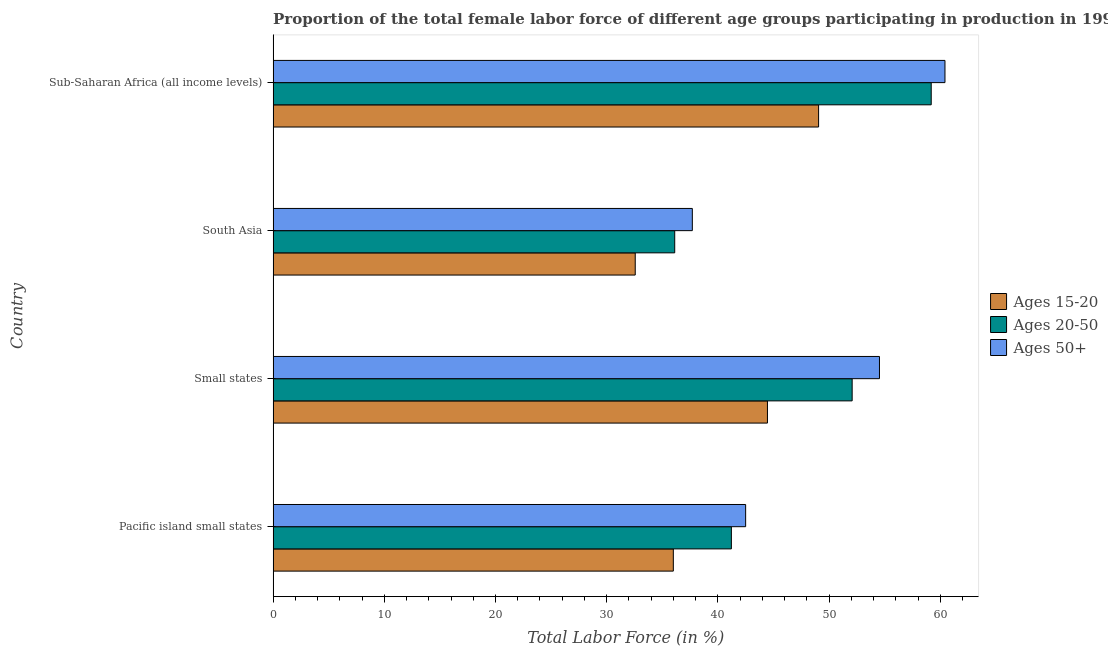How many different coloured bars are there?
Your answer should be very brief. 3. Are the number of bars on each tick of the Y-axis equal?
Keep it short and to the point. Yes. How many bars are there on the 1st tick from the top?
Provide a succinct answer. 3. What is the label of the 4th group of bars from the top?
Your response must be concise. Pacific island small states. In how many cases, is the number of bars for a given country not equal to the number of legend labels?
Your answer should be compact. 0. What is the percentage of female labor force within the age group 15-20 in Pacific island small states?
Provide a short and direct response. 35.99. Across all countries, what is the maximum percentage of female labor force within the age group 15-20?
Your answer should be very brief. 49.06. Across all countries, what is the minimum percentage of female labor force above age 50?
Offer a terse response. 37.7. In which country was the percentage of female labor force within the age group 20-50 maximum?
Offer a very short reply. Sub-Saharan Africa (all income levels). What is the total percentage of female labor force within the age group 20-50 in the graph?
Provide a succinct answer. 188.6. What is the difference between the percentage of female labor force within the age group 20-50 in Small states and that in Sub-Saharan Africa (all income levels)?
Your response must be concise. -7.11. What is the difference between the percentage of female labor force within the age group 20-50 in South Asia and the percentage of female labor force within the age group 15-20 in Small states?
Provide a succinct answer. -8.34. What is the average percentage of female labor force within the age group 15-20 per country?
Keep it short and to the point. 40.52. What is the difference between the percentage of female labor force above age 50 and percentage of female labor force within the age group 15-20 in Small states?
Provide a short and direct response. 10.07. In how many countries, is the percentage of female labor force within the age group 20-50 greater than 44 %?
Keep it short and to the point. 2. What is the ratio of the percentage of female labor force within the age group 20-50 in Small states to that in South Asia?
Your response must be concise. 1.44. What is the difference between the highest and the second highest percentage of female labor force within the age group 20-50?
Offer a very short reply. 7.11. What is the difference between the highest and the lowest percentage of female labor force within the age group 20-50?
Provide a short and direct response. 23.07. Is the sum of the percentage of female labor force above age 50 in Small states and Sub-Saharan Africa (all income levels) greater than the maximum percentage of female labor force within the age group 20-50 across all countries?
Ensure brevity in your answer.  Yes. What does the 2nd bar from the top in Pacific island small states represents?
Provide a short and direct response. Ages 20-50. What does the 2nd bar from the bottom in Sub-Saharan Africa (all income levels) represents?
Your response must be concise. Ages 20-50. Is it the case that in every country, the sum of the percentage of female labor force within the age group 15-20 and percentage of female labor force within the age group 20-50 is greater than the percentage of female labor force above age 50?
Your response must be concise. Yes. Are all the bars in the graph horizontal?
Keep it short and to the point. Yes. How many countries are there in the graph?
Your answer should be compact. 4. What is the difference between two consecutive major ticks on the X-axis?
Give a very brief answer. 10. Does the graph contain any zero values?
Ensure brevity in your answer.  No. Does the graph contain grids?
Ensure brevity in your answer.  No. What is the title of the graph?
Make the answer very short. Proportion of the total female labor force of different age groups participating in production in 1991. Does "Textiles and clothing" appear as one of the legend labels in the graph?
Provide a succinct answer. No. What is the label or title of the X-axis?
Make the answer very short. Total Labor Force (in %). What is the label or title of the Y-axis?
Your answer should be very brief. Country. What is the Total Labor Force (in %) of Ages 15-20 in Pacific island small states?
Provide a succinct answer. 35.99. What is the Total Labor Force (in %) in Ages 20-50 in Pacific island small states?
Give a very brief answer. 41.21. What is the Total Labor Force (in %) of Ages 50+ in Pacific island small states?
Your answer should be compact. 42.5. What is the Total Labor Force (in %) in Ages 15-20 in Small states?
Your answer should be compact. 44.46. What is the Total Labor Force (in %) of Ages 20-50 in Small states?
Offer a terse response. 52.08. What is the Total Labor Force (in %) in Ages 50+ in Small states?
Ensure brevity in your answer.  54.53. What is the Total Labor Force (in %) in Ages 15-20 in South Asia?
Provide a succinct answer. 32.57. What is the Total Labor Force (in %) of Ages 20-50 in South Asia?
Provide a short and direct response. 36.12. What is the Total Labor Force (in %) in Ages 50+ in South Asia?
Give a very brief answer. 37.7. What is the Total Labor Force (in %) in Ages 15-20 in Sub-Saharan Africa (all income levels)?
Give a very brief answer. 49.06. What is the Total Labor Force (in %) in Ages 20-50 in Sub-Saharan Africa (all income levels)?
Offer a very short reply. 59.19. What is the Total Labor Force (in %) in Ages 50+ in Sub-Saharan Africa (all income levels)?
Provide a short and direct response. 60.42. Across all countries, what is the maximum Total Labor Force (in %) in Ages 15-20?
Provide a succinct answer. 49.06. Across all countries, what is the maximum Total Labor Force (in %) of Ages 20-50?
Your answer should be compact. 59.19. Across all countries, what is the maximum Total Labor Force (in %) of Ages 50+?
Your response must be concise. 60.42. Across all countries, what is the minimum Total Labor Force (in %) in Ages 15-20?
Your answer should be very brief. 32.57. Across all countries, what is the minimum Total Labor Force (in %) of Ages 20-50?
Your answer should be very brief. 36.12. Across all countries, what is the minimum Total Labor Force (in %) of Ages 50+?
Provide a short and direct response. 37.7. What is the total Total Labor Force (in %) in Ages 15-20 in the graph?
Offer a very short reply. 162.08. What is the total Total Labor Force (in %) in Ages 20-50 in the graph?
Make the answer very short. 188.6. What is the total Total Labor Force (in %) of Ages 50+ in the graph?
Ensure brevity in your answer.  195.16. What is the difference between the Total Labor Force (in %) of Ages 15-20 in Pacific island small states and that in Small states?
Your answer should be compact. -8.47. What is the difference between the Total Labor Force (in %) in Ages 20-50 in Pacific island small states and that in Small states?
Your answer should be compact. -10.86. What is the difference between the Total Labor Force (in %) of Ages 50+ in Pacific island small states and that in Small states?
Offer a very short reply. -12.04. What is the difference between the Total Labor Force (in %) of Ages 15-20 in Pacific island small states and that in South Asia?
Offer a very short reply. 3.43. What is the difference between the Total Labor Force (in %) of Ages 20-50 in Pacific island small states and that in South Asia?
Make the answer very short. 5.1. What is the difference between the Total Labor Force (in %) in Ages 50+ in Pacific island small states and that in South Asia?
Keep it short and to the point. 4.79. What is the difference between the Total Labor Force (in %) of Ages 15-20 in Pacific island small states and that in Sub-Saharan Africa (all income levels)?
Your answer should be very brief. -13.07. What is the difference between the Total Labor Force (in %) in Ages 20-50 in Pacific island small states and that in Sub-Saharan Africa (all income levels)?
Your answer should be very brief. -17.97. What is the difference between the Total Labor Force (in %) in Ages 50+ in Pacific island small states and that in Sub-Saharan Africa (all income levels)?
Provide a short and direct response. -17.93. What is the difference between the Total Labor Force (in %) of Ages 15-20 in Small states and that in South Asia?
Give a very brief answer. 11.89. What is the difference between the Total Labor Force (in %) in Ages 20-50 in Small states and that in South Asia?
Keep it short and to the point. 15.96. What is the difference between the Total Labor Force (in %) of Ages 50+ in Small states and that in South Asia?
Keep it short and to the point. 16.83. What is the difference between the Total Labor Force (in %) in Ages 15-20 in Small states and that in Sub-Saharan Africa (all income levels)?
Keep it short and to the point. -4.6. What is the difference between the Total Labor Force (in %) in Ages 20-50 in Small states and that in Sub-Saharan Africa (all income levels)?
Ensure brevity in your answer.  -7.11. What is the difference between the Total Labor Force (in %) in Ages 50+ in Small states and that in Sub-Saharan Africa (all income levels)?
Offer a terse response. -5.89. What is the difference between the Total Labor Force (in %) of Ages 15-20 in South Asia and that in Sub-Saharan Africa (all income levels)?
Your answer should be very brief. -16.49. What is the difference between the Total Labor Force (in %) of Ages 20-50 in South Asia and that in Sub-Saharan Africa (all income levels)?
Your answer should be very brief. -23.07. What is the difference between the Total Labor Force (in %) of Ages 50+ in South Asia and that in Sub-Saharan Africa (all income levels)?
Provide a short and direct response. -22.72. What is the difference between the Total Labor Force (in %) in Ages 15-20 in Pacific island small states and the Total Labor Force (in %) in Ages 20-50 in Small states?
Provide a succinct answer. -16.08. What is the difference between the Total Labor Force (in %) in Ages 15-20 in Pacific island small states and the Total Labor Force (in %) in Ages 50+ in Small states?
Your answer should be compact. -18.54. What is the difference between the Total Labor Force (in %) in Ages 20-50 in Pacific island small states and the Total Labor Force (in %) in Ages 50+ in Small states?
Your response must be concise. -13.32. What is the difference between the Total Labor Force (in %) of Ages 15-20 in Pacific island small states and the Total Labor Force (in %) of Ages 20-50 in South Asia?
Your response must be concise. -0.12. What is the difference between the Total Labor Force (in %) in Ages 15-20 in Pacific island small states and the Total Labor Force (in %) in Ages 50+ in South Asia?
Offer a very short reply. -1.71. What is the difference between the Total Labor Force (in %) in Ages 20-50 in Pacific island small states and the Total Labor Force (in %) in Ages 50+ in South Asia?
Keep it short and to the point. 3.51. What is the difference between the Total Labor Force (in %) in Ages 15-20 in Pacific island small states and the Total Labor Force (in %) in Ages 20-50 in Sub-Saharan Africa (all income levels)?
Ensure brevity in your answer.  -23.19. What is the difference between the Total Labor Force (in %) of Ages 15-20 in Pacific island small states and the Total Labor Force (in %) of Ages 50+ in Sub-Saharan Africa (all income levels)?
Your answer should be very brief. -24.43. What is the difference between the Total Labor Force (in %) in Ages 20-50 in Pacific island small states and the Total Labor Force (in %) in Ages 50+ in Sub-Saharan Africa (all income levels)?
Your response must be concise. -19.21. What is the difference between the Total Labor Force (in %) of Ages 15-20 in Small states and the Total Labor Force (in %) of Ages 20-50 in South Asia?
Provide a succinct answer. 8.34. What is the difference between the Total Labor Force (in %) of Ages 15-20 in Small states and the Total Labor Force (in %) of Ages 50+ in South Asia?
Your response must be concise. 6.76. What is the difference between the Total Labor Force (in %) in Ages 20-50 in Small states and the Total Labor Force (in %) in Ages 50+ in South Asia?
Provide a short and direct response. 14.37. What is the difference between the Total Labor Force (in %) in Ages 15-20 in Small states and the Total Labor Force (in %) in Ages 20-50 in Sub-Saharan Africa (all income levels)?
Ensure brevity in your answer.  -14.73. What is the difference between the Total Labor Force (in %) of Ages 15-20 in Small states and the Total Labor Force (in %) of Ages 50+ in Sub-Saharan Africa (all income levels)?
Offer a very short reply. -15.97. What is the difference between the Total Labor Force (in %) in Ages 20-50 in Small states and the Total Labor Force (in %) in Ages 50+ in Sub-Saharan Africa (all income levels)?
Your answer should be compact. -8.35. What is the difference between the Total Labor Force (in %) of Ages 15-20 in South Asia and the Total Labor Force (in %) of Ages 20-50 in Sub-Saharan Africa (all income levels)?
Your answer should be compact. -26.62. What is the difference between the Total Labor Force (in %) in Ages 15-20 in South Asia and the Total Labor Force (in %) in Ages 50+ in Sub-Saharan Africa (all income levels)?
Your answer should be compact. -27.86. What is the difference between the Total Labor Force (in %) in Ages 20-50 in South Asia and the Total Labor Force (in %) in Ages 50+ in Sub-Saharan Africa (all income levels)?
Make the answer very short. -24.31. What is the average Total Labor Force (in %) of Ages 15-20 per country?
Make the answer very short. 40.52. What is the average Total Labor Force (in %) in Ages 20-50 per country?
Provide a short and direct response. 47.15. What is the average Total Labor Force (in %) of Ages 50+ per country?
Keep it short and to the point. 48.79. What is the difference between the Total Labor Force (in %) of Ages 15-20 and Total Labor Force (in %) of Ages 20-50 in Pacific island small states?
Your answer should be very brief. -5.22. What is the difference between the Total Labor Force (in %) in Ages 15-20 and Total Labor Force (in %) in Ages 50+ in Pacific island small states?
Your response must be concise. -6.5. What is the difference between the Total Labor Force (in %) in Ages 20-50 and Total Labor Force (in %) in Ages 50+ in Pacific island small states?
Offer a terse response. -1.28. What is the difference between the Total Labor Force (in %) in Ages 15-20 and Total Labor Force (in %) in Ages 20-50 in Small states?
Your answer should be compact. -7.62. What is the difference between the Total Labor Force (in %) of Ages 15-20 and Total Labor Force (in %) of Ages 50+ in Small states?
Offer a very short reply. -10.07. What is the difference between the Total Labor Force (in %) in Ages 20-50 and Total Labor Force (in %) in Ages 50+ in Small states?
Give a very brief answer. -2.46. What is the difference between the Total Labor Force (in %) in Ages 15-20 and Total Labor Force (in %) in Ages 20-50 in South Asia?
Your response must be concise. -3.55. What is the difference between the Total Labor Force (in %) in Ages 15-20 and Total Labor Force (in %) in Ages 50+ in South Asia?
Your answer should be very brief. -5.14. What is the difference between the Total Labor Force (in %) of Ages 20-50 and Total Labor Force (in %) of Ages 50+ in South Asia?
Keep it short and to the point. -1.58. What is the difference between the Total Labor Force (in %) of Ages 15-20 and Total Labor Force (in %) of Ages 20-50 in Sub-Saharan Africa (all income levels)?
Provide a short and direct response. -10.13. What is the difference between the Total Labor Force (in %) of Ages 15-20 and Total Labor Force (in %) of Ages 50+ in Sub-Saharan Africa (all income levels)?
Provide a short and direct response. -11.37. What is the difference between the Total Labor Force (in %) in Ages 20-50 and Total Labor Force (in %) in Ages 50+ in Sub-Saharan Africa (all income levels)?
Your answer should be compact. -1.24. What is the ratio of the Total Labor Force (in %) of Ages 15-20 in Pacific island small states to that in Small states?
Provide a succinct answer. 0.81. What is the ratio of the Total Labor Force (in %) of Ages 20-50 in Pacific island small states to that in Small states?
Your answer should be compact. 0.79. What is the ratio of the Total Labor Force (in %) in Ages 50+ in Pacific island small states to that in Small states?
Ensure brevity in your answer.  0.78. What is the ratio of the Total Labor Force (in %) of Ages 15-20 in Pacific island small states to that in South Asia?
Make the answer very short. 1.11. What is the ratio of the Total Labor Force (in %) in Ages 20-50 in Pacific island small states to that in South Asia?
Make the answer very short. 1.14. What is the ratio of the Total Labor Force (in %) of Ages 50+ in Pacific island small states to that in South Asia?
Your answer should be very brief. 1.13. What is the ratio of the Total Labor Force (in %) in Ages 15-20 in Pacific island small states to that in Sub-Saharan Africa (all income levels)?
Your response must be concise. 0.73. What is the ratio of the Total Labor Force (in %) in Ages 20-50 in Pacific island small states to that in Sub-Saharan Africa (all income levels)?
Ensure brevity in your answer.  0.7. What is the ratio of the Total Labor Force (in %) of Ages 50+ in Pacific island small states to that in Sub-Saharan Africa (all income levels)?
Ensure brevity in your answer.  0.7. What is the ratio of the Total Labor Force (in %) in Ages 15-20 in Small states to that in South Asia?
Make the answer very short. 1.37. What is the ratio of the Total Labor Force (in %) in Ages 20-50 in Small states to that in South Asia?
Provide a succinct answer. 1.44. What is the ratio of the Total Labor Force (in %) of Ages 50+ in Small states to that in South Asia?
Your response must be concise. 1.45. What is the ratio of the Total Labor Force (in %) of Ages 15-20 in Small states to that in Sub-Saharan Africa (all income levels)?
Your answer should be very brief. 0.91. What is the ratio of the Total Labor Force (in %) of Ages 20-50 in Small states to that in Sub-Saharan Africa (all income levels)?
Your answer should be very brief. 0.88. What is the ratio of the Total Labor Force (in %) of Ages 50+ in Small states to that in Sub-Saharan Africa (all income levels)?
Keep it short and to the point. 0.9. What is the ratio of the Total Labor Force (in %) of Ages 15-20 in South Asia to that in Sub-Saharan Africa (all income levels)?
Your answer should be compact. 0.66. What is the ratio of the Total Labor Force (in %) in Ages 20-50 in South Asia to that in Sub-Saharan Africa (all income levels)?
Your response must be concise. 0.61. What is the ratio of the Total Labor Force (in %) in Ages 50+ in South Asia to that in Sub-Saharan Africa (all income levels)?
Ensure brevity in your answer.  0.62. What is the difference between the highest and the second highest Total Labor Force (in %) of Ages 15-20?
Your response must be concise. 4.6. What is the difference between the highest and the second highest Total Labor Force (in %) of Ages 20-50?
Your answer should be very brief. 7.11. What is the difference between the highest and the second highest Total Labor Force (in %) of Ages 50+?
Ensure brevity in your answer.  5.89. What is the difference between the highest and the lowest Total Labor Force (in %) of Ages 15-20?
Offer a very short reply. 16.49. What is the difference between the highest and the lowest Total Labor Force (in %) of Ages 20-50?
Give a very brief answer. 23.07. What is the difference between the highest and the lowest Total Labor Force (in %) in Ages 50+?
Provide a short and direct response. 22.72. 